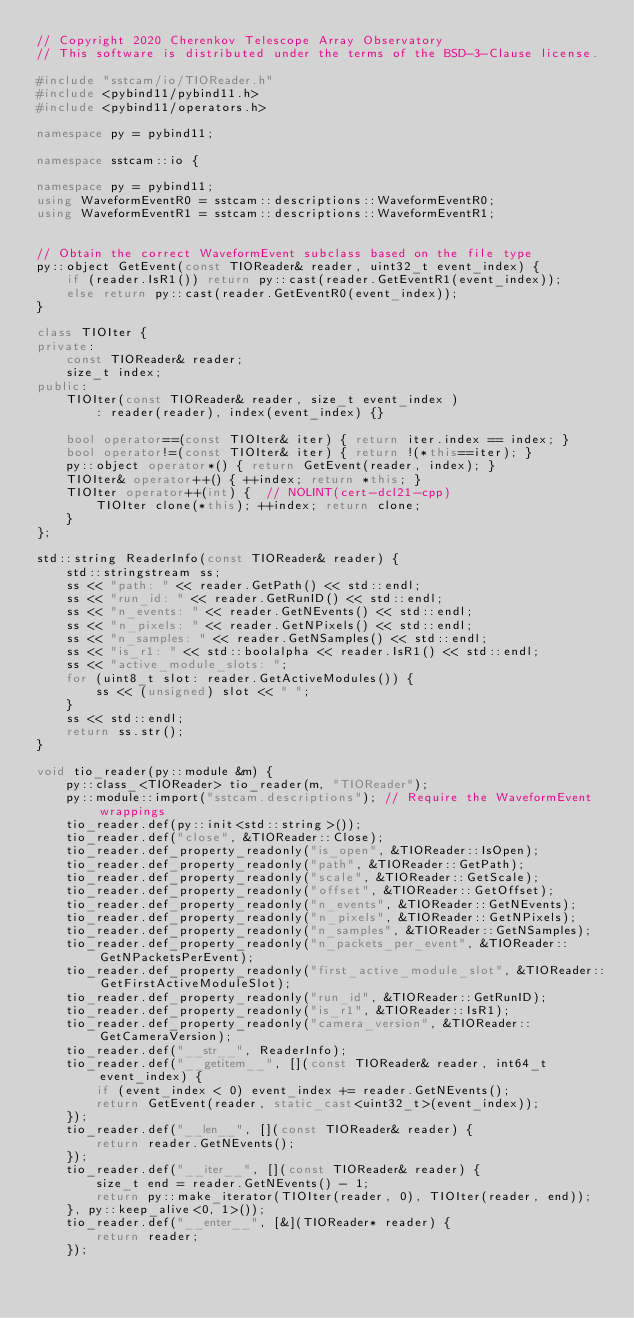Convert code to text. <code><loc_0><loc_0><loc_500><loc_500><_C++_>// Copyright 2020 Cherenkov Telescope Array Observatory
// This software is distributed under the terms of the BSD-3-Clause license.

#include "sstcam/io/TIOReader.h"
#include <pybind11/pybind11.h>
#include <pybind11/operators.h>

namespace py = pybind11;

namespace sstcam::io {

namespace py = pybind11;
using WaveformEventR0 = sstcam::descriptions::WaveformEventR0;
using WaveformEventR1 = sstcam::descriptions::WaveformEventR1;


// Obtain the correct WaveformEvent subclass based on the file type
py::object GetEvent(const TIOReader& reader, uint32_t event_index) {
    if (reader.IsR1()) return py::cast(reader.GetEventR1(event_index));
    else return py::cast(reader.GetEventR0(event_index));
}

class TIOIter {
private:
    const TIOReader& reader;
    size_t index;
public:
    TIOIter(const TIOReader& reader, size_t event_index )
        : reader(reader), index(event_index) {}

    bool operator==(const TIOIter& iter) { return iter.index == index; }
    bool operator!=(const TIOIter& iter) { return !(*this==iter); }
    py::object operator*() { return GetEvent(reader, index); }
    TIOIter& operator++() { ++index; return *this; }
    TIOIter operator++(int) {  // NOLINT(cert-dcl21-cpp)
        TIOIter clone(*this); ++index; return clone;
    }
};

std::string ReaderInfo(const TIOReader& reader) {
    std::stringstream ss;
    ss << "path: " << reader.GetPath() << std::endl;
    ss << "run_id: " << reader.GetRunID() << std::endl;
    ss << "n_events: " << reader.GetNEvents() << std::endl;
    ss << "n_pixels: " << reader.GetNPixels() << std::endl;
    ss << "n_samples: " << reader.GetNSamples() << std::endl;
    ss << "is_r1: " << std::boolalpha << reader.IsR1() << std::endl;
    ss << "active_module_slots: ";
    for (uint8_t slot: reader.GetActiveModules()) {
        ss << (unsigned) slot << " ";
    }
    ss << std::endl;
    return ss.str();
}

void tio_reader(py::module &m) {
    py::class_<TIOReader> tio_reader(m, "TIOReader");
    py::module::import("sstcam.descriptions"); // Require the WaveformEvent wrappings
    tio_reader.def(py::init<std::string>());
    tio_reader.def("close", &TIOReader::Close);
    tio_reader.def_property_readonly("is_open", &TIOReader::IsOpen);
    tio_reader.def_property_readonly("path", &TIOReader::GetPath);
    tio_reader.def_property_readonly("scale", &TIOReader::GetScale);
    tio_reader.def_property_readonly("offset", &TIOReader::GetOffset);
    tio_reader.def_property_readonly("n_events", &TIOReader::GetNEvents);
    tio_reader.def_property_readonly("n_pixels", &TIOReader::GetNPixels);
    tio_reader.def_property_readonly("n_samples", &TIOReader::GetNSamples);
    tio_reader.def_property_readonly("n_packets_per_event", &TIOReader::GetNPacketsPerEvent);
    tio_reader.def_property_readonly("first_active_module_slot", &TIOReader::GetFirstActiveModuleSlot);
    tio_reader.def_property_readonly("run_id", &TIOReader::GetRunID);
    tio_reader.def_property_readonly("is_r1", &TIOReader::IsR1);
    tio_reader.def_property_readonly("camera_version", &TIOReader::GetCameraVersion);
    tio_reader.def("__str__", ReaderInfo);
    tio_reader.def("__getitem__", [](const TIOReader& reader, int64_t event_index) {
        if (event_index < 0) event_index += reader.GetNEvents();
        return GetEvent(reader, static_cast<uint32_t>(event_index));
    });
    tio_reader.def("__len__", [](const TIOReader& reader) {
        return reader.GetNEvents();
    });
    tio_reader.def("__iter__", [](const TIOReader& reader) {
        size_t end = reader.GetNEvents() - 1;
        return py::make_iterator(TIOIter(reader, 0), TIOIter(reader, end));
    }, py::keep_alive<0, 1>());
    tio_reader.def("__enter__", [&](TIOReader* reader) {
        return reader;
    });</code> 